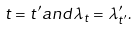<formula> <loc_0><loc_0><loc_500><loc_500>t = t ^ { \prime } a n d \lambda _ { t } = \lambda ^ { \prime } _ { t ^ { \prime } } .</formula> 